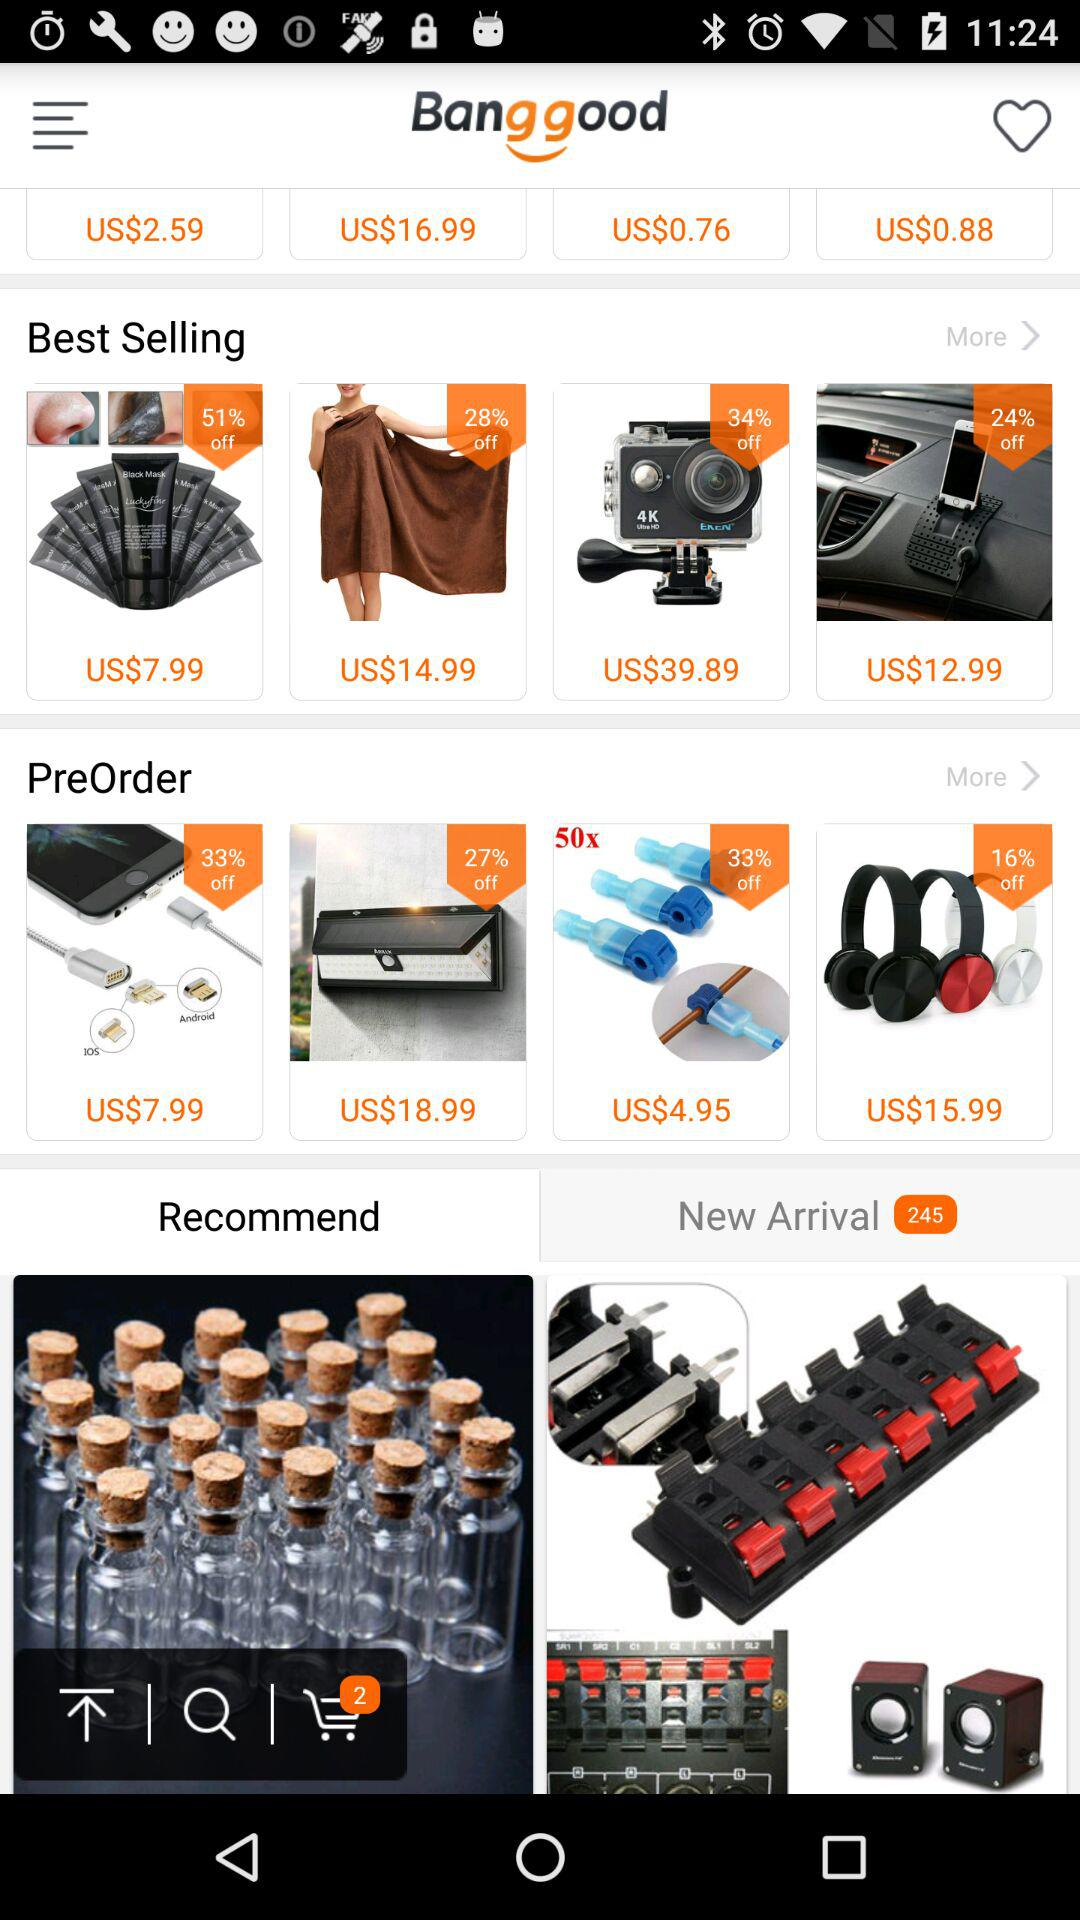What is the total number of items in "New Arrival"? There are 245 items in "New Arrival". 